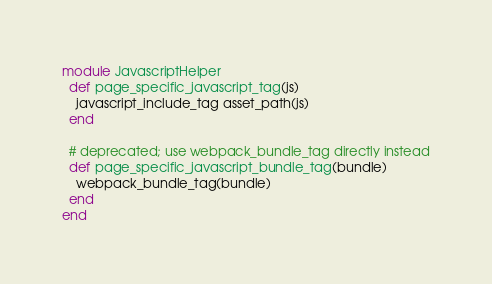Convert code to text. <code><loc_0><loc_0><loc_500><loc_500><_Ruby_>module JavascriptHelper
  def page_specific_javascript_tag(js)
    javascript_include_tag asset_path(js)
  end

  # deprecated; use webpack_bundle_tag directly instead
  def page_specific_javascript_bundle_tag(bundle)
    webpack_bundle_tag(bundle)
  end
end
</code> 